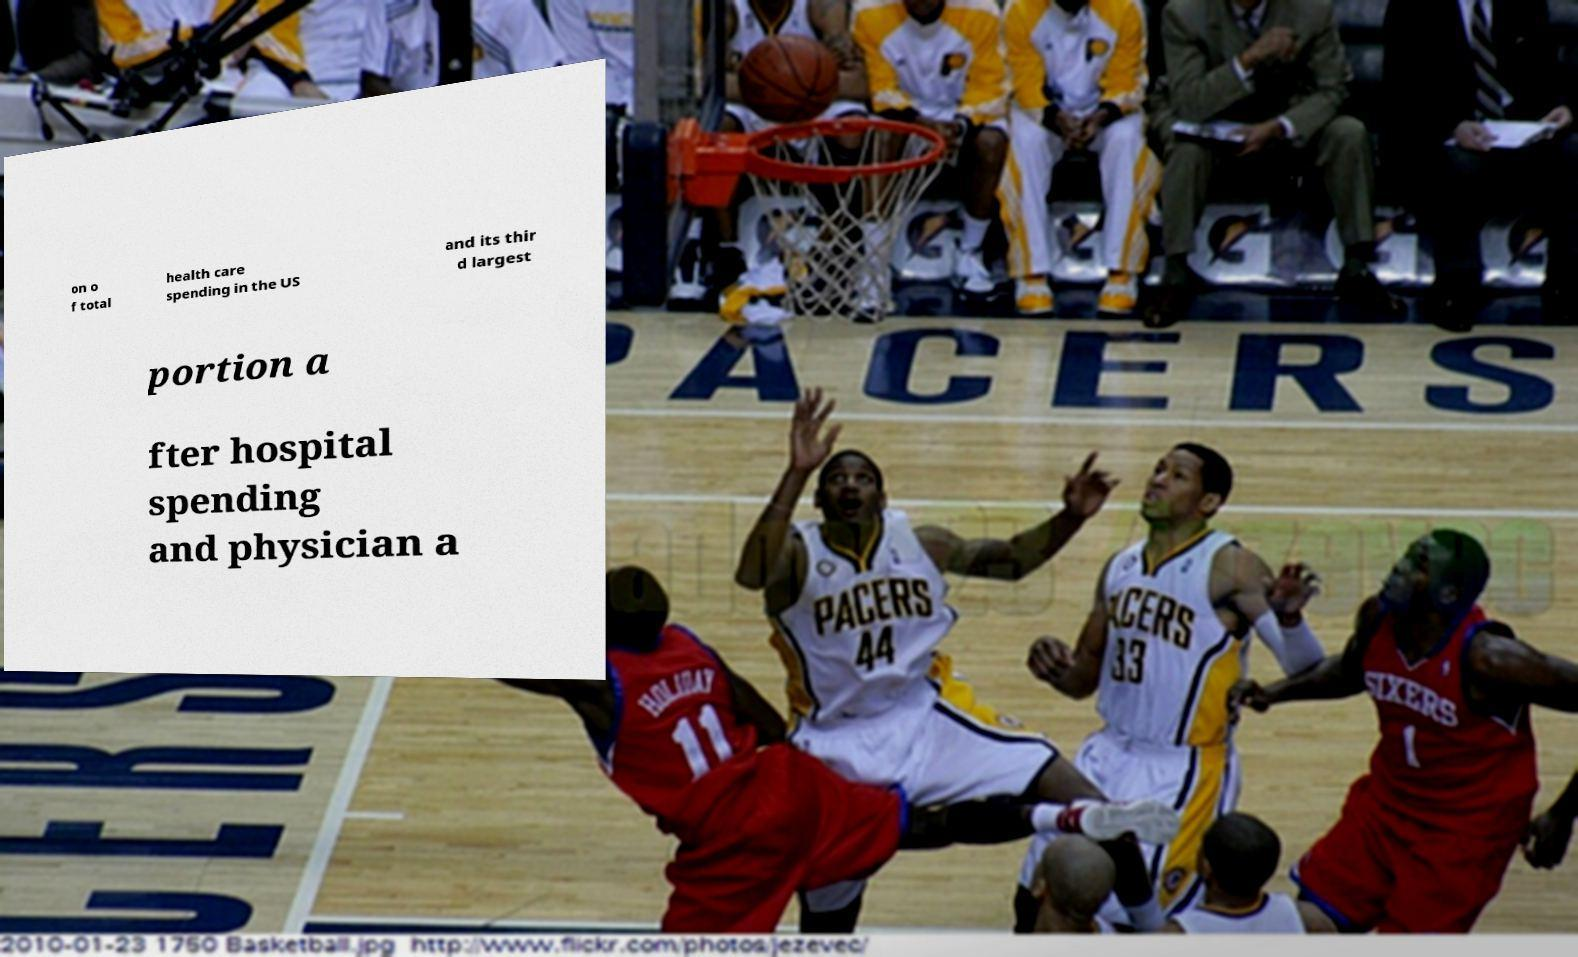There's text embedded in this image that I need extracted. Can you transcribe it verbatim? on o f total health care spending in the US and its thir d largest portion a fter hospital spending and physician a 